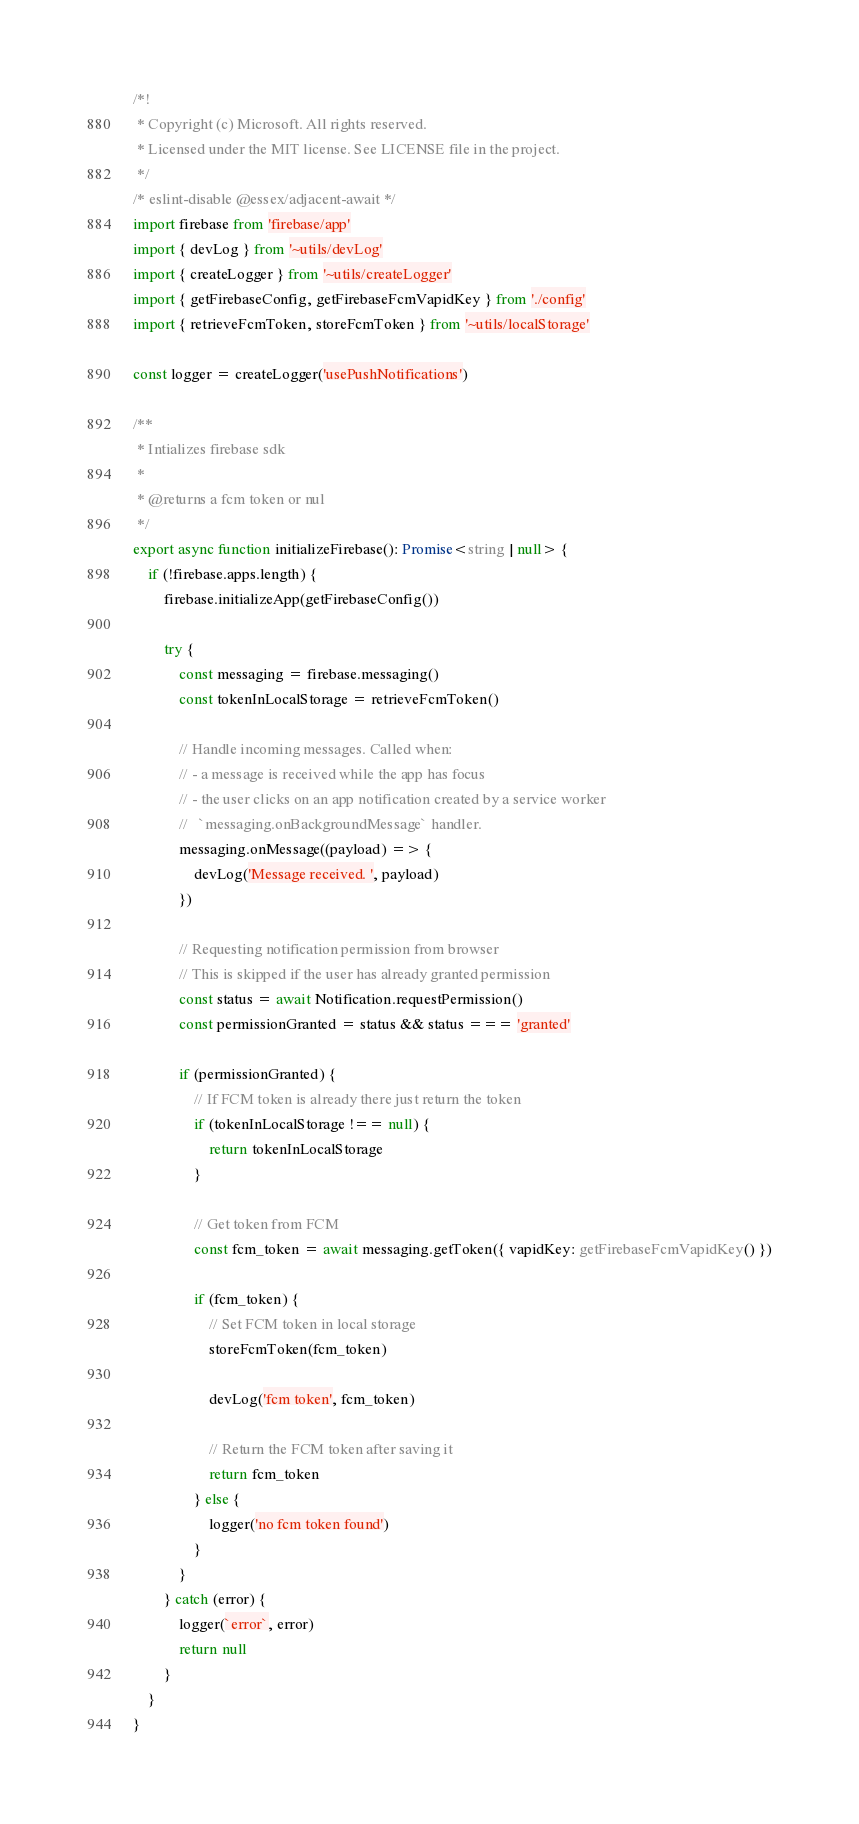<code> <loc_0><loc_0><loc_500><loc_500><_TypeScript_>/*!
 * Copyright (c) Microsoft. All rights reserved.
 * Licensed under the MIT license. See LICENSE file in the project.
 */
/* eslint-disable @essex/adjacent-await */
import firebase from 'firebase/app'
import { devLog } from '~utils/devLog'
import { createLogger } from '~utils/createLogger'
import { getFirebaseConfig, getFirebaseFcmVapidKey } from './config'
import { retrieveFcmToken, storeFcmToken } from '~utils/localStorage'

const logger = createLogger('usePushNotifications')

/**
 * Intializes firebase sdk
 *
 * @returns a fcm token or nul
 */
export async function initializeFirebase(): Promise<string | null> {
	if (!firebase.apps.length) {
		firebase.initializeApp(getFirebaseConfig())

		try {
			const messaging = firebase.messaging()
			const tokenInLocalStorage = retrieveFcmToken()

			// Handle incoming messages. Called when:
			// - a message is received while the app has focus
			// - the user clicks on an app notification created by a service worker
			//   `messaging.onBackgroundMessage` handler.
			messaging.onMessage((payload) => {
				devLog('Message received. ', payload)
			})

			// Requesting notification permission from browser
			// This is skipped if the user has already granted permission
			const status = await Notification.requestPermission()
			const permissionGranted = status && status === 'granted'

			if (permissionGranted) {
				// If FCM token is already there just return the token
				if (tokenInLocalStorage !== null) {
					return tokenInLocalStorage
				}

				// Get token from FCM
				const fcm_token = await messaging.getToken({ vapidKey: getFirebaseFcmVapidKey() })

				if (fcm_token) {
					// Set FCM token in local storage
					storeFcmToken(fcm_token)

					devLog('fcm token', fcm_token)

					// Return the FCM token after saving it
					return fcm_token
				} else {
					logger('no fcm token found')
				}
			}
		} catch (error) {
			logger(`error`, error)
			return null
		}
	}
}
</code> 